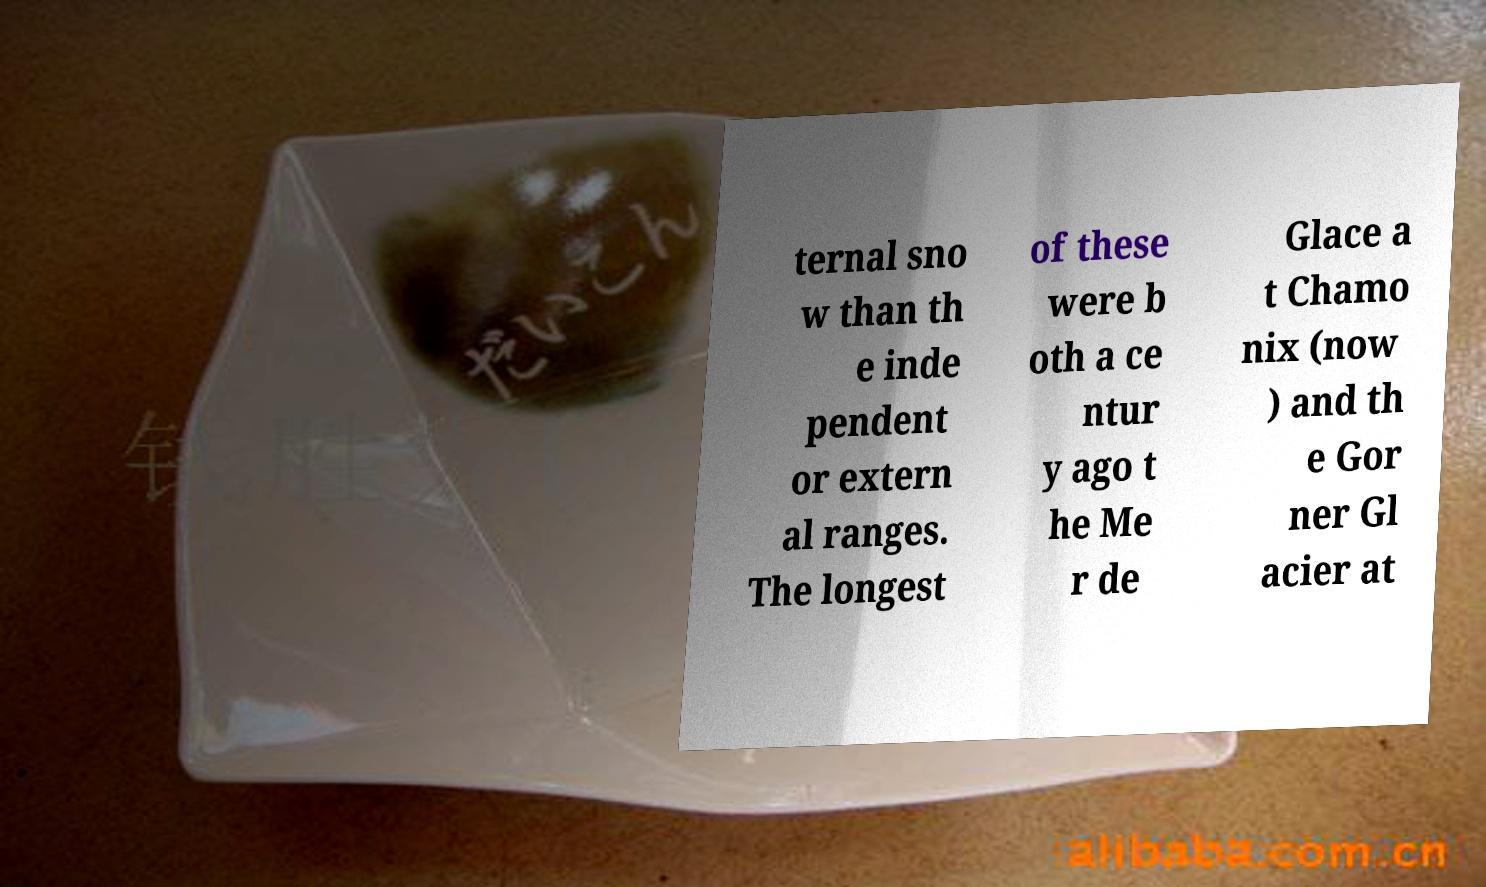Can you read and provide the text displayed in the image?This photo seems to have some interesting text. Can you extract and type it out for me? ternal sno w than th e inde pendent or extern al ranges. The longest of these were b oth a ce ntur y ago t he Me r de Glace a t Chamo nix (now ) and th e Gor ner Gl acier at 